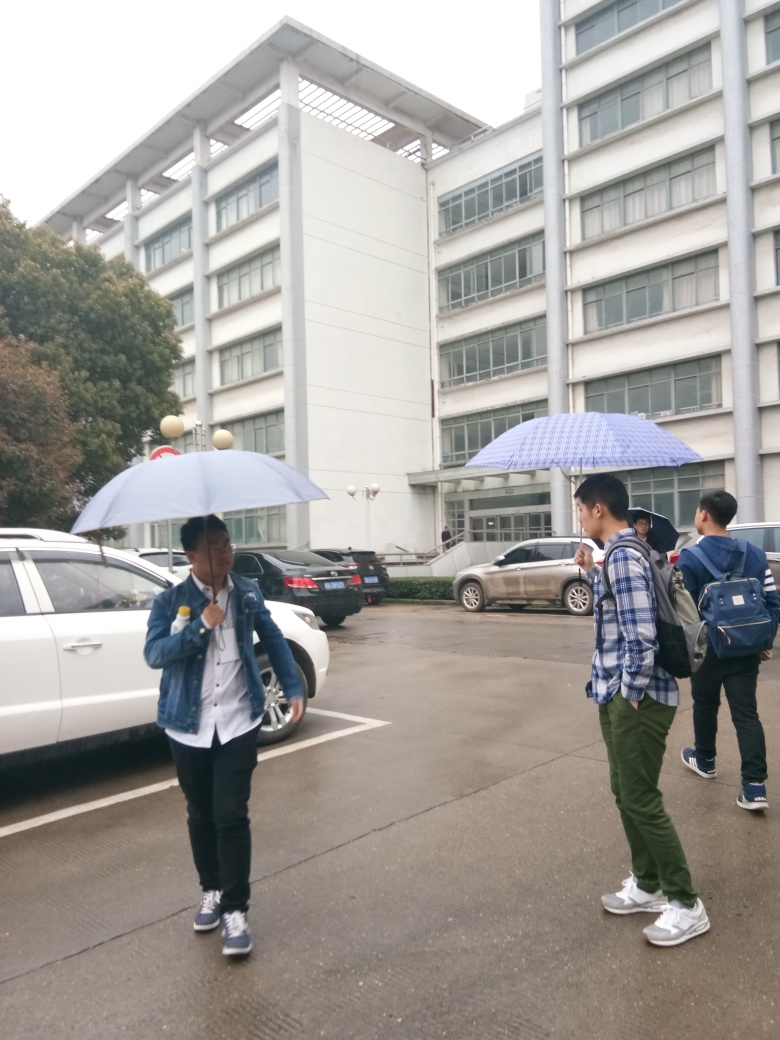Is the focus normal? The focus appears slightly soft, particularly towards the background. This could be due to the camera settings or motion blur. The subjects in the foreground are reasonably sharp, although improving the focus would enhance overall clarity. 